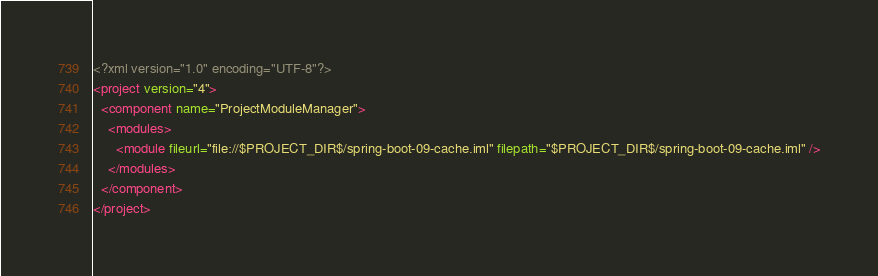<code> <loc_0><loc_0><loc_500><loc_500><_XML_><?xml version="1.0" encoding="UTF-8"?>
<project version="4">
  <component name="ProjectModuleManager">
    <modules>
      <module fileurl="file://$PROJECT_DIR$/spring-boot-09-cache.iml" filepath="$PROJECT_DIR$/spring-boot-09-cache.iml" />
    </modules>
  </component>
</project></code> 